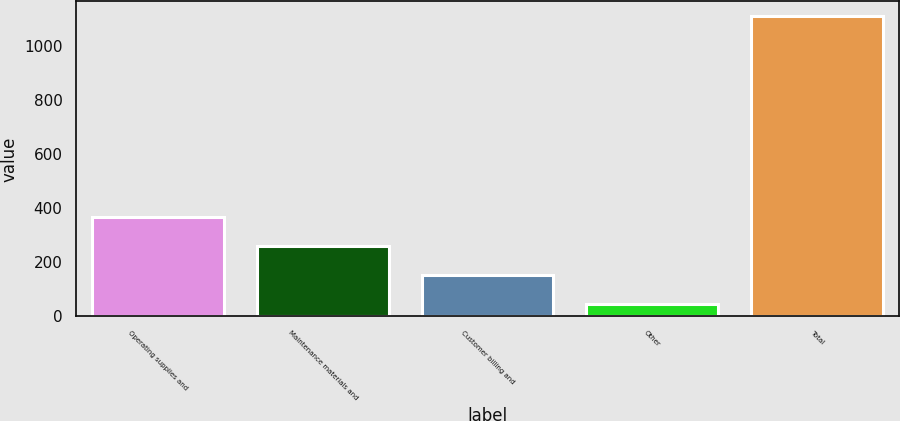<chart> <loc_0><loc_0><loc_500><loc_500><bar_chart><fcel>Operating supplies and<fcel>Maintenance materials and<fcel>Customer billing and<fcel>Other<fcel>Total<nl><fcel>366.5<fcel>260<fcel>153.5<fcel>47<fcel>1112<nl></chart> 